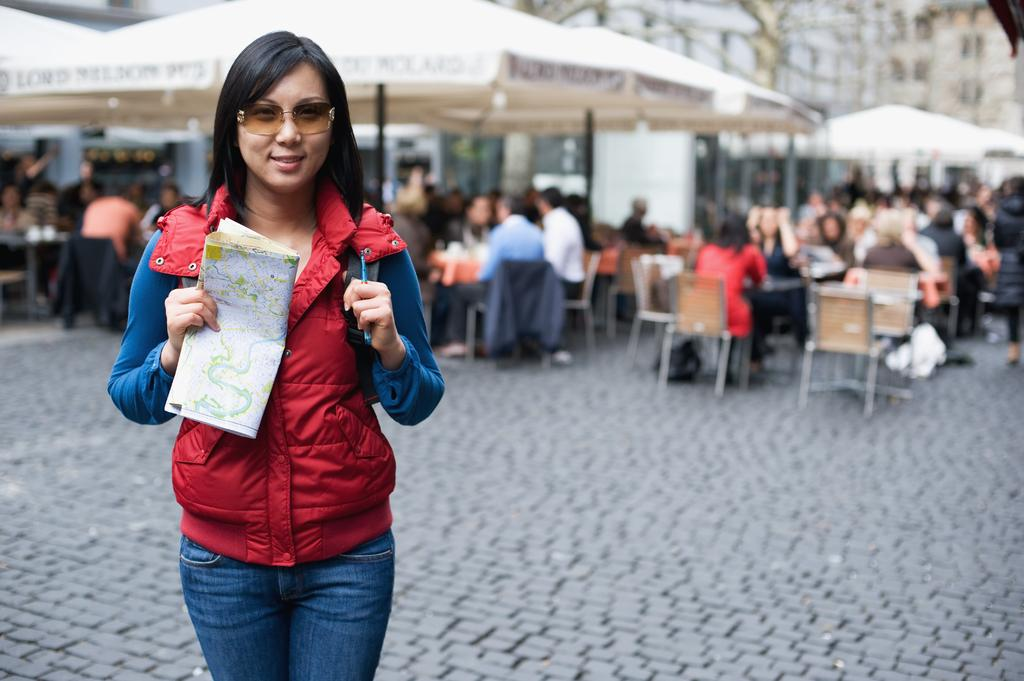Who is present in the image? There is a woman in the image. What is the woman doing in the image? The woman is standing and smiling. What is the woman holding in the image? The woman is holding a paper and a pen. What can be seen in the image besides the woman? There are umbrellas and a group of people sitting on chairs in the image. How would you describe the background of the image? The background of the image is blurred. What type of shop can be seen in the background of the image? There is no shop visible in the image; the background is blurred. What kind of laborer is working on the umbrellas in the image? There are no laborers present in the image, and the umbrellas are not being worked on. 